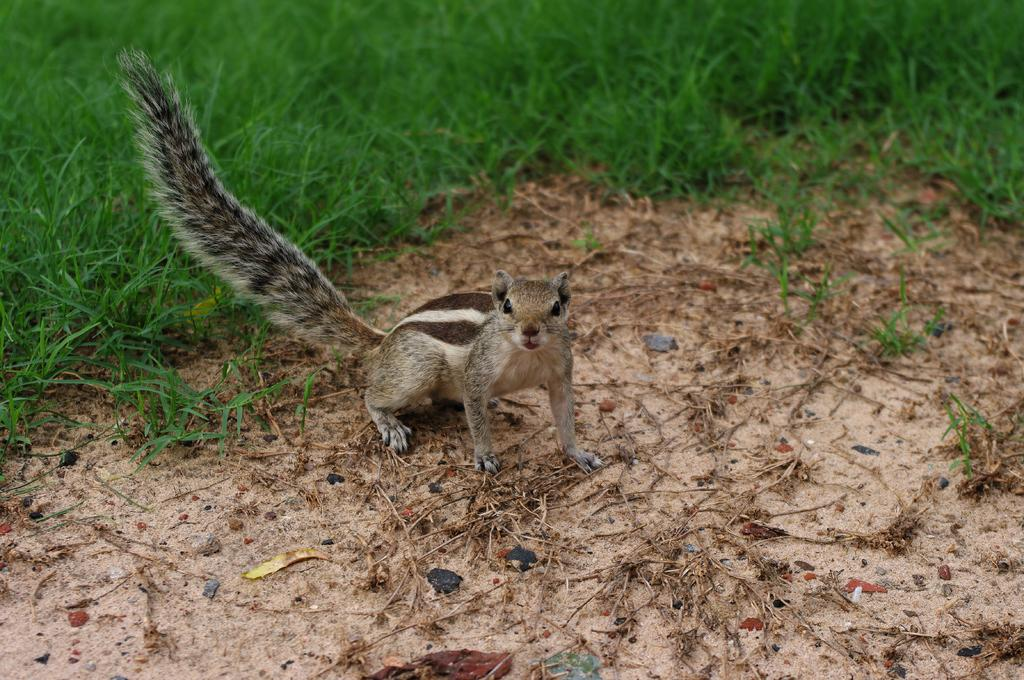What type of animal is in the image? There is a squirrel in the image. Where is the squirrel located in the image? The squirrel is on the ground. What type of vegetation can be seen in the background of the image? There is grass visible in the background of the image. Can you see any islands in the image? There are no islands visible in the image. What type of butter is being used by the squirrel in the image? There is no butter present in the image, and the squirrel is not using any. 